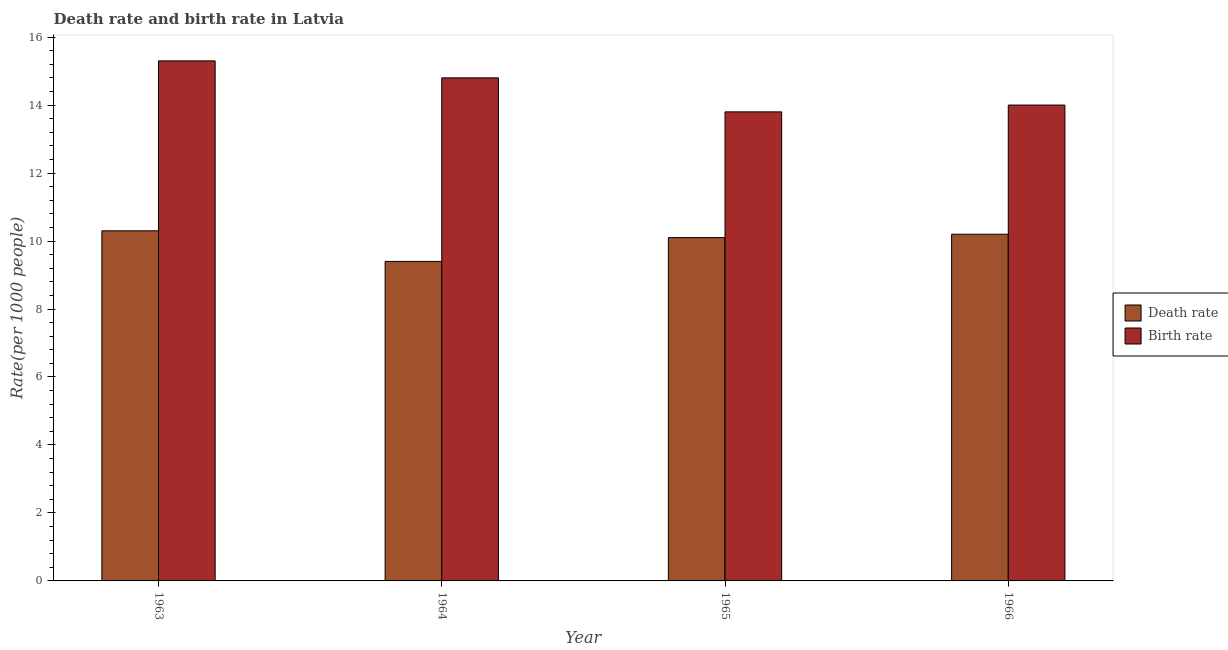How many different coloured bars are there?
Keep it short and to the point. 2. How many groups of bars are there?
Give a very brief answer. 4. Are the number of bars per tick equal to the number of legend labels?
Your answer should be very brief. Yes. How many bars are there on the 3rd tick from the right?
Your answer should be very brief. 2. What is the label of the 3rd group of bars from the left?
Offer a very short reply. 1965. In which year was the birth rate minimum?
Your answer should be compact. 1965. What is the total birth rate in the graph?
Your answer should be very brief. 57.9. What is the difference between the death rate in 1964 and that in 1966?
Keep it short and to the point. -0.8. What is the difference between the death rate in 1963 and the birth rate in 1965?
Keep it short and to the point. 0.2. What is the average death rate per year?
Your answer should be compact. 10. In the year 1965, what is the difference between the death rate and birth rate?
Your answer should be very brief. 0. What is the ratio of the birth rate in 1963 to that in 1966?
Your answer should be compact. 1.09. What is the difference between the highest and the second highest death rate?
Offer a very short reply. 0.1. What is the difference between the highest and the lowest death rate?
Provide a short and direct response. 0.9. Is the sum of the birth rate in 1963 and 1965 greater than the maximum death rate across all years?
Keep it short and to the point. Yes. What does the 2nd bar from the left in 1964 represents?
Offer a very short reply. Birth rate. What does the 1st bar from the right in 1965 represents?
Offer a very short reply. Birth rate. How many bars are there?
Your answer should be very brief. 8. Are all the bars in the graph horizontal?
Provide a succinct answer. No. Are the values on the major ticks of Y-axis written in scientific E-notation?
Your answer should be very brief. No. Does the graph contain any zero values?
Your answer should be compact. No. Where does the legend appear in the graph?
Offer a very short reply. Center right. What is the title of the graph?
Offer a very short reply. Death rate and birth rate in Latvia. Does "Merchandise imports" appear as one of the legend labels in the graph?
Provide a short and direct response. No. What is the label or title of the Y-axis?
Provide a succinct answer. Rate(per 1000 people). What is the Rate(per 1000 people) of Birth rate in 1963?
Offer a very short reply. 15.3. What is the Rate(per 1000 people) in Birth rate in 1964?
Make the answer very short. 14.8. What is the Rate(per 1000 people) in Birth rate in 1965?
Offer a terse response. 13.8. What is the Rate(per 1000 people) in Death rate in 1966?
Keep it short and to the point. 10.2. What is the Rate(per 1000 people) of Birth rate in 1966?
Provide a short and direct response. 14. Across all years, what is the maximum Rate(per 1000 people) in Death rate?
Give a very brief answer. 10.3. Across all years, what is the maximum Rate(per 1000 people) of Birth rate?
Your response must be concise. 15.3. Across all years, what is the minimum Rate(per 1000 people) of Death rate?
Your answer should be compact. 9.4. What is the total Rate(per 1000 people) in Birth rate in the graph?
Your response must be concise. 57.9. What is the difference between the Rate(per 1000 people) in Death rate in 1963 and that in 1965?
Offer a very short reply. 0.2. What is the difference between the Rate(per 1000 people) of Death rate in 1963 and that in 1966?
Provide a succinct answer. 0.1. What is the difference between the Rate(per 1000 people) in Birth rate in 1963 and that in 1966?
Give a very brief answer. 1.3. What is the difference between the Rate(per 1000 people) in Death rate in 1964 and that in 1965?
Make the answer very short. -0.7. What is the difference between the Rate(per 1000 people) in Birth rate in 1964 and that in 1966?
Provide a succinct answer. 0.8. What is the difference between the Rate(per 1000 people) in Death rate in 1965 and that in 1966?
Offer a very short reply. -0.1. What is the difference between the Rate(per 1000 people) of Birth rate in 1965 and that in 1966?
Your answer should be very brief. -0.2. What is the difference between the Rate(per 1000 people) in Death rate in 1963 and the Rate(per 1000 people) in Birth rate in 1964?
Give a very brief answer. -4.5. What is the difference between the Rate(per 1000 people) in Death rate in 1963 and the Rate(per 1000 people) in Birth rate in 1965?
Your answer should be very brief. -3.5. What is the difference between the Rate(per 1000 people) of Death rate in 1963 and the Rate(per 1000 people) of Birth rate in 1966?
Your response must be concise. -3.7. What is the difference between the Rate(per 1000 people) in Death rate in 1964 and the Rate(per 1000 people) in Birth rate in 1965?
Provide a short and direct response. -4.4. What is the average Rate(per 1000 people) of Birth rate per year?
Your answer should be very brief. 14.47. In the year 1963, what is the difference between the Rate(per 1000 people) of Death rate and Rate(per 1000 people) of Birth rate?
Keep it short and to the point. -5. In the year 1965, what is the difference between the Rate(per 1000 people) in Death rate and Rate(per 1000 people) in Birth rate?
Offer a terse response. -3.7. In the year 1966, what is the difference between the Rate(per 1000 people) of Death rate and Rate(per 1000 people) of Birth rate?
Offer a terse response. -3.8. What is the ratio of the Rate(per 1000 people) of Death rate in 1963 to that in 1964?
Make the answer very short. 1.1. What is the ratio of the Rate(per 1000 people) of Birth rate in 1963 to that in 1964?
Provide a short and direct response. 1.03. What is the ratio of the Rate(per 1000 people) in Death rate in 1963 to that in 1965?
Offer a very short reply. 1.02. What is the ratio of the Rate(per 1000 people) of Birth rate in 1963 to that in 1965?
Keep it short and to the point. 1.11. What is the ratio of the Rate(per 1000 people) of Death rate in 1963 to that in 1966?
Provide a short and direct response. 1.01. What is the ratio of the Rate(per 1000 people) in Birth rate in 1963 to that in 1966?
Offer a very short reply. 1.09. What is the ratio of the Rate(per 1000 people) in Death rate in 1964 to that in 1965?
Keep it short and to the point. 0.93. What is the ratio of the Rate(per 1000 people) in Birth rate in 1964 to that in 1965?
Offer a very short reply. 1.07. What is the ratio of the Rate(per 1000 people) of Death rate in 1964 to that in 1966?
Your answer should be compact. 0.92. What is the ratio of the Rate(per 1000 people) in Birth rate in 1964 to that in 1966?
Make the answer very short. 1.06. What is the ratio of the Rate(per 1000 people) of Death rate in 1965 to that in 1966?
Keep it short and to the point. 0.99. What is the ratio of the Rate(per 1000 people) in Birth rate in 1965 to that in 1966?
Make the answer very short. 0.99. 